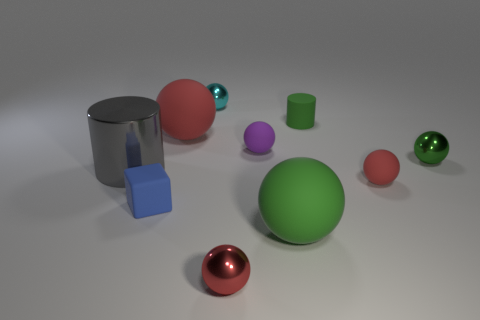Can you describe the lighting and shadow effects in this scene? The image is illuminated with what appears to be diffuse overhead lighting, casting soft shadows on the ground. The shadows are less pronounced and spread out, suggesting the light source is not extremely close to the objects. This lighting setup gives the scene a calm and balanced ambiance, with all objects clearly visible and accurately revealing their shapes and textures. 